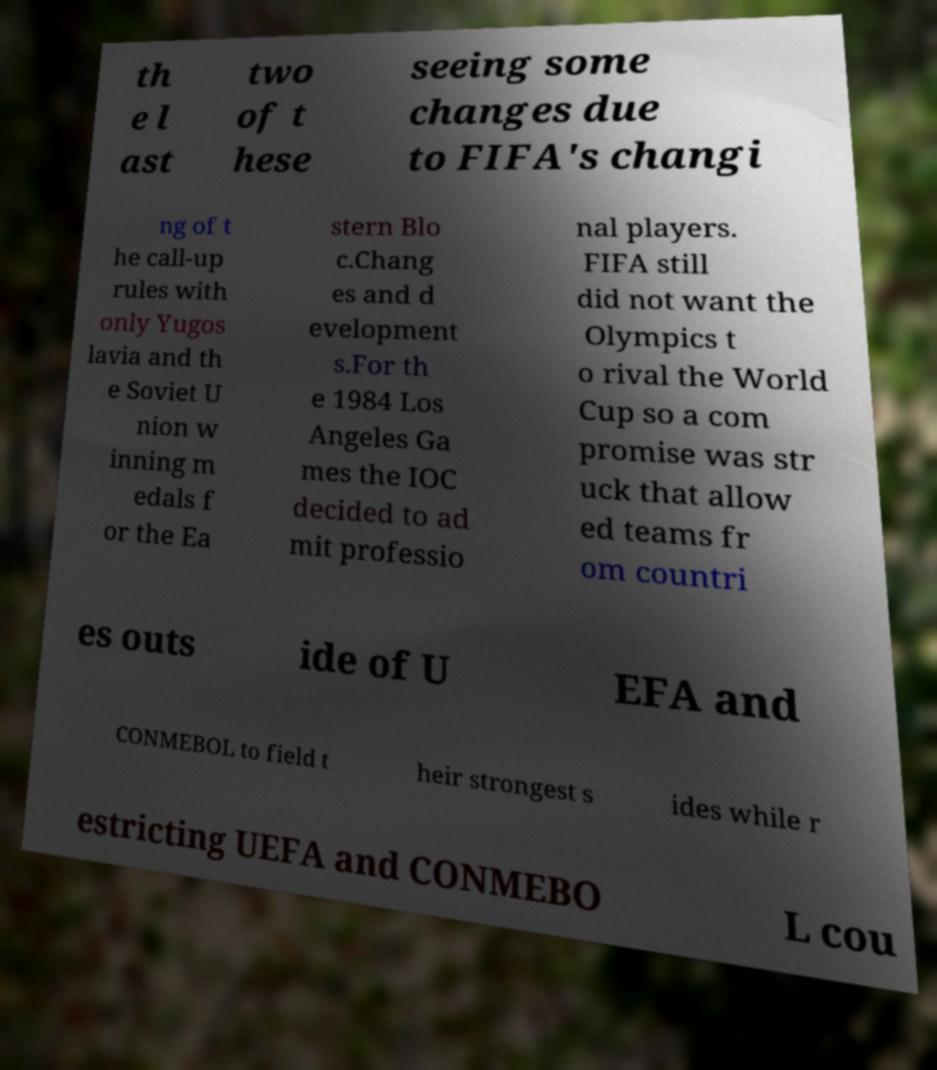I need the written content from this picture converted into text. Can you do that? th e l ast two of t hese seeing some changes due to FIFA's changi ng of t he call-up rules with only Yugos lavia and th e Soviet U nion w inning m edals f or the Ea stern Blo c.Chang es and d evelopment s.For th e 1984 Los Angeles Ga mes the IOC decided to ad mit professio nal players. FIFA still did not want the Olympics t o rival the World Cup so a com promise was str uck that allow ed teams fr om countri es outs ide of U EFA and CONMEBOL to field t heir strongest s ides while r estricting UEFA and CONMEBO L cou 